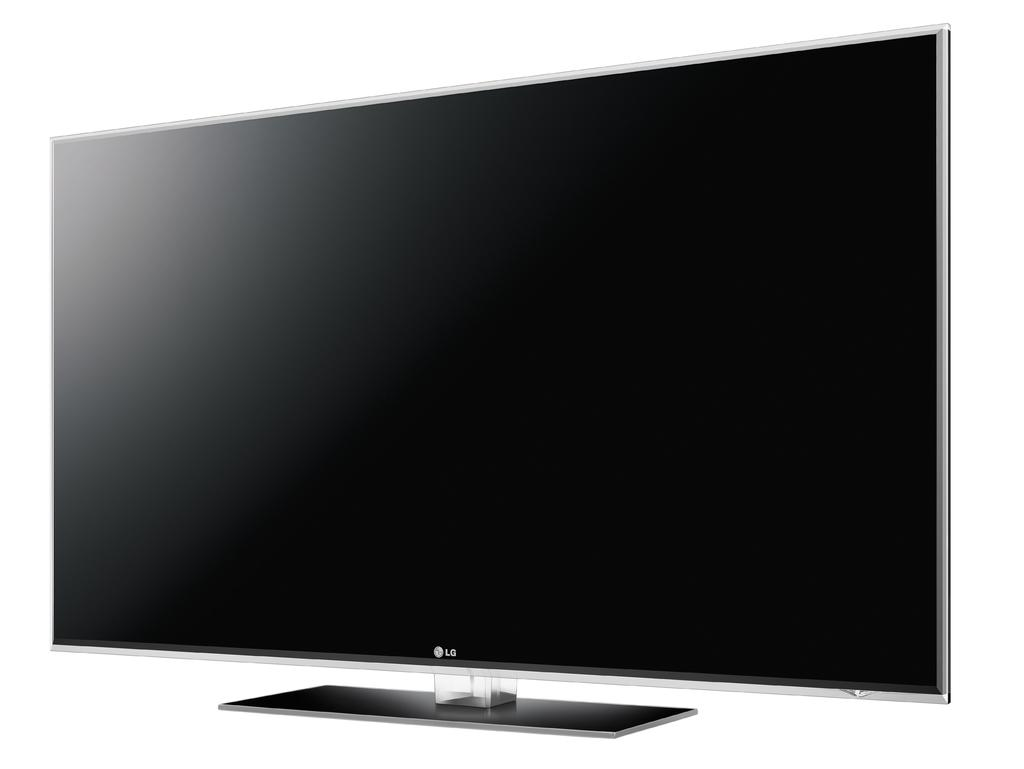<image>
Describe the image concisely. An LG, flat screen TV is displayed at a slight angle. 